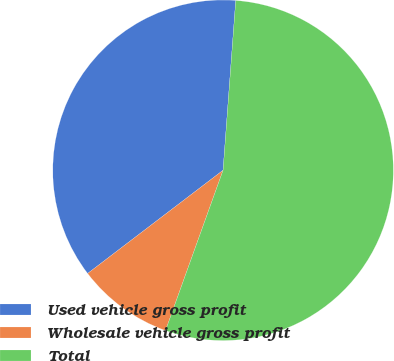<chart> <loc_0><loc_0><loc_500><loc_500><pie_chart><fcel>Used vehicle gross profit<fcel>Wholesale vehicle gross profit<fcel>Total<nl><fcel>36.55%<fcel>9.15%<fcel>54.3%<nl></chart> 